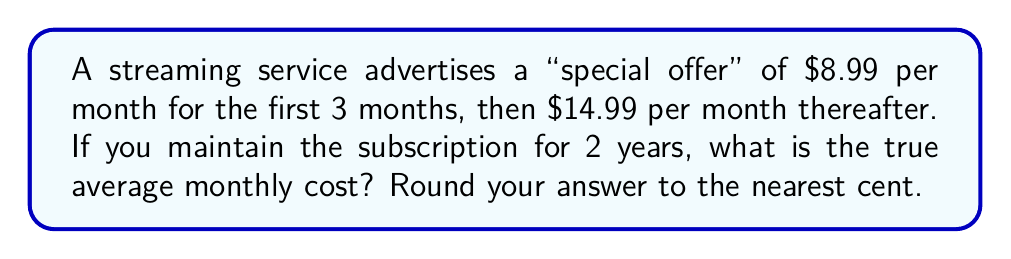Can you answer this question? Let's approach this step-by-step:

1) First, calculate the cost for the first 3 months:
   $3 \times $8.99 = $26.97

2) Now, calculate the cost for the remaining 21 months:
   $21 \times $14.99 = $314.79

3) Add these together to get the total cost for 2 years:
   $26.97 + $314.79 = $341.76

4) To find the average monthly cost, divide the total by 24 months:
   $$\frac{$341.76}{24} = $14.24$$

5) Rounding to the nearest cent gives us $14.24.

This calculation reveals that the "special offer" only slightly reduces the overall cost compared to the regular price of $14.99 per month. A skeptical consumer might note that the advertised low introductory rate is not representative of the true long-term cost of the service.
Answer: $14.24 per month 